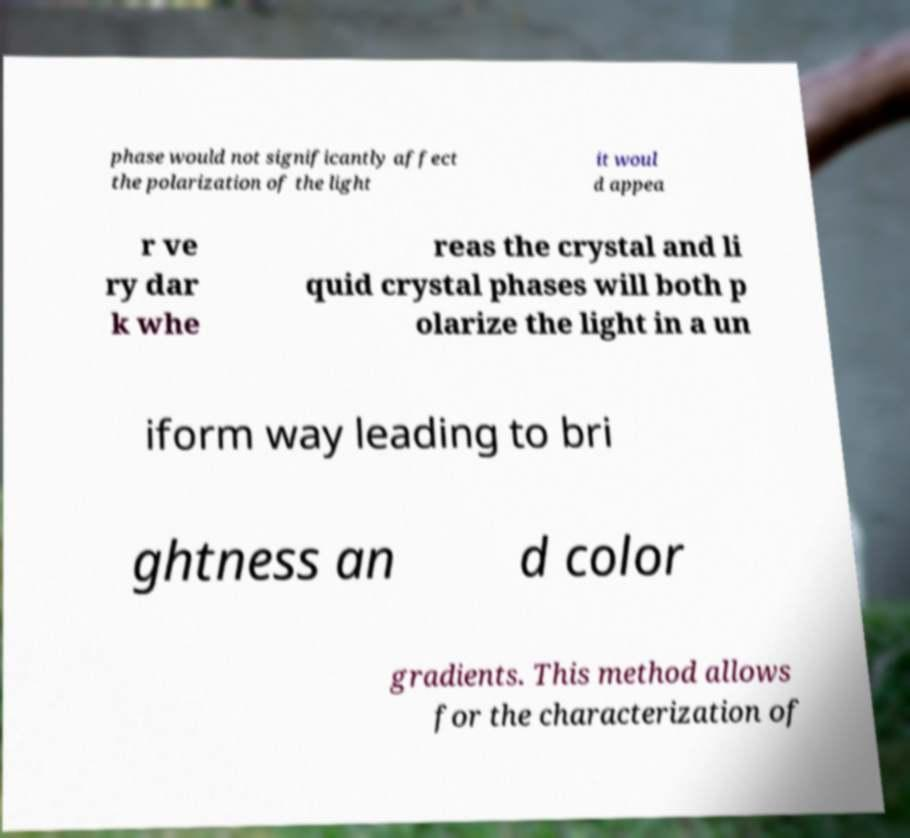Could you assist in decoding the text presented in this image and type it out clearly? phase would not significantly affect the polarization of the light it woul d appea r ve ry dar k whe reas the crystal and li quid crystal phases will both p olarize the light in a un iform way leading to bri ghtness an d color gradients. This method allows for the characterization of 